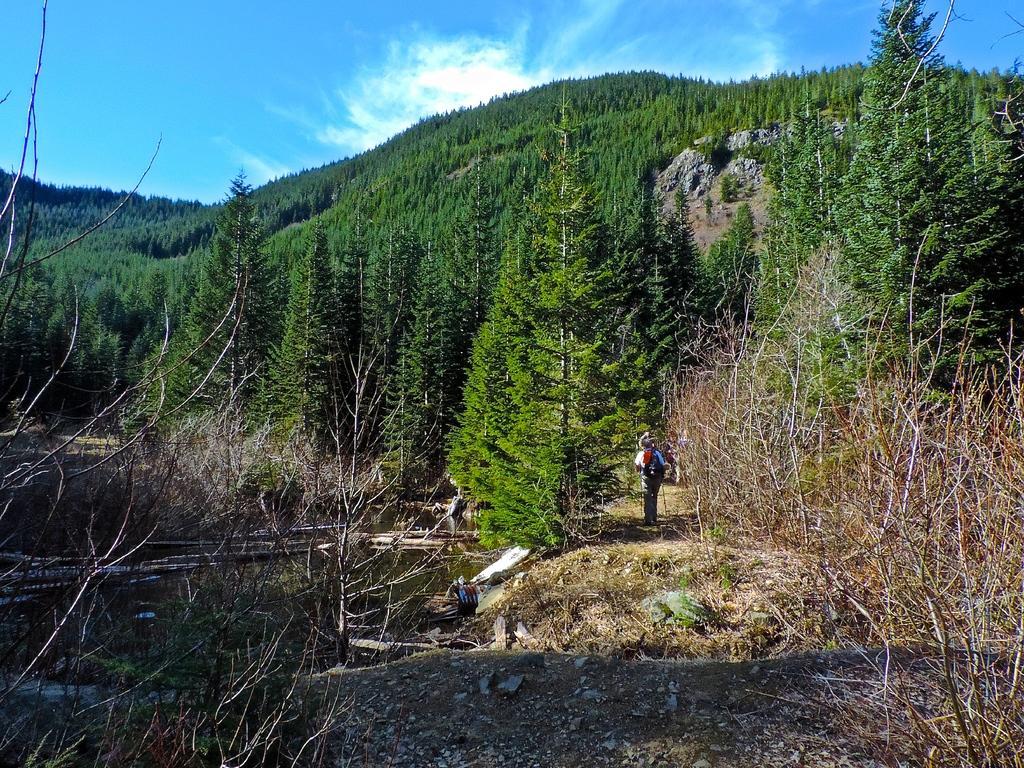Could you give a brief overview of what you see in this image? In this picture we can see trees, grass and water. In the background of the image we can see the sky with clouds. 